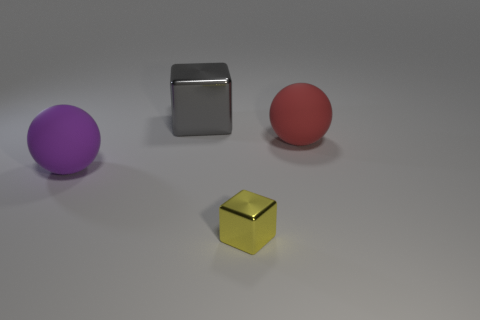Add 1 large yellow rubber cubes. How many objects exist? 5 Subtract all purple balls. How many balls are left? 1 Subtract 1 balls. How many balls are left? 1 Subtract all blue spheres. How many yellow cubes are left? 1 Subtract all gray cubes. Subtract all green balls. How many cubes are left? 1 Subtract all large metallic cubes. Subtract all big cyan matte things. How many objects are left? 3 Add 2 yellow metallic objects. How many yellow metallic objects are left? 3 Add 3 purple spheres. How many purple spheres exist? 4 Subtract 0 cyan balls. How many objects are left? 4 